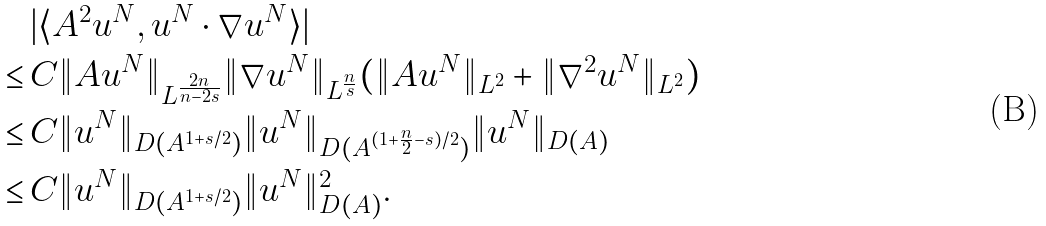<formula> <loc_0><loc_0><loc_500><loc_500>& \, | \langle A ^ { 2 } u ^ { N } , u ^ { N } \cdot \nabla u ^ { N } \rangle | \\ \leq & \, C \| A u ^ { N } \| _ { L ^ { \frac { 2 n } { n - 2 s } } } \| \nabla u ^ { N } \| _ { L ^ { \frac { n } { s } } } ( \| A u ^ { N } \| _ { L ^ { 2 } } + \| \nabla ^ { 2 } u ^ { N } \| _ { L ^ { 2 } } ) \\ \leq & \, C \| u ^ { N } \| _ { D ( A ^ { 1 + s / 2 } ) } \| u ^ { N } \| _ { D ( A ^ { ( 1 + \frac { n } { 2 } - s ) / 2 } ) } \| u ^ { N } \| _ { D ( A ) } \\ \leq & \, C \| u ^ { N } \| _ { D ( A ^ { 1 + s / 2 } ) } \| u ^ { N } \| _ { D ( A ) } ^ { 2 } .</formula> 